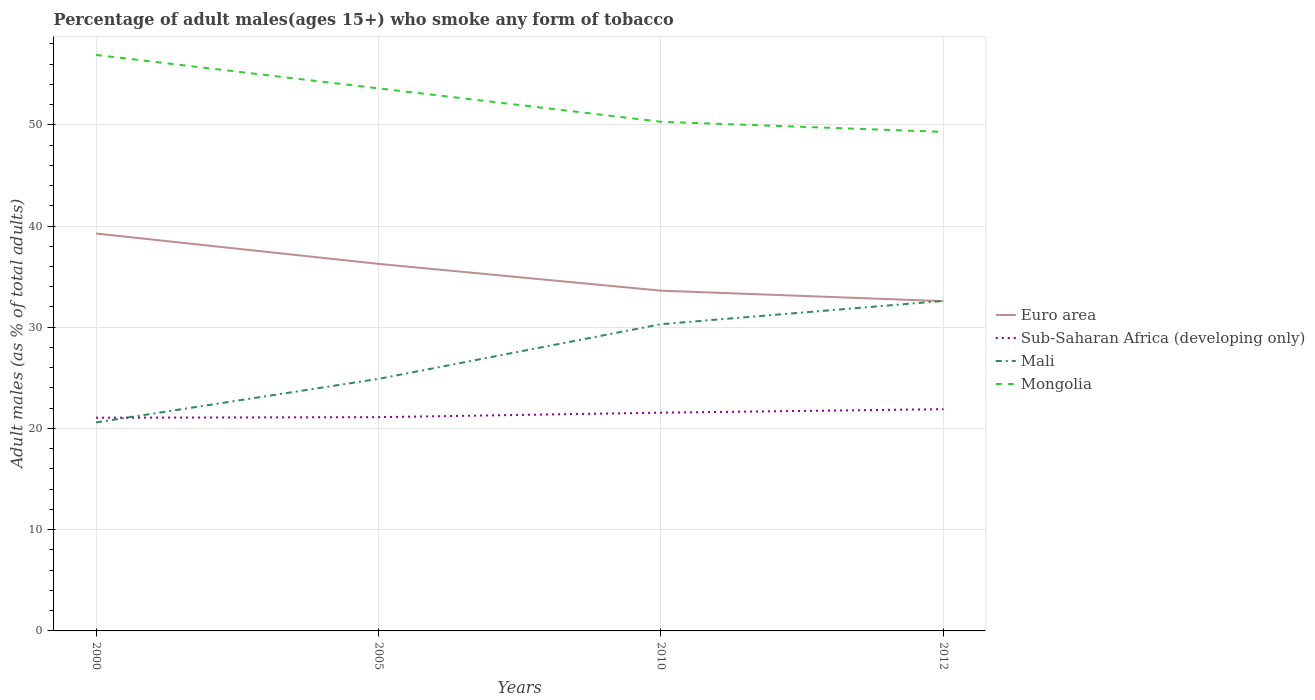How many different coloured lines are there?
Keep it short and to the point. 4. Across all years, what is the maximum percentage of adult males who smoke in Mongolia?
Give a very brief answer. 49.3. What is the total percentage of adult males who smoke in Euro area in the graph?
Your answer should be very brief. 3.68. What is the difference between the highest and the second highest percentage of adult males who smoke in Euro area?
Make the answer very short. 6.68. Is the percentage of adult males who smoke in Sub-Saharan Africa (developing only) strictly greater than the percentage of adult males who smoke in Mongolia over the years?
Make the answer very short. Yes. How many lines are there?
Your response must be concise. 4. How many years are there in the graph?
Provide a short and direct response. 4. Are the values on the major ticks of Y-axis written in scientific E-notation?
Give a very brief answer. No. Does the graph contain grids?
Offer a terse response. Yes. Where does the legend appear in the graph?
Provide a short and direct response. Center right. What is the title of the graph?
Keep it short and to the point. Percentage of adult males(ages 15+) who smoke any form of tobacco. What is the label or title of the Y-axis?
Make the answer very short. Adult males (as % of total adults). What is the Adult males (as % of total adults) in Euro area in 2000?
Give a very brief answer. 39.26. What is the Adult males (as % of total adults) in Sub-Saharan Africa (developing only) in 2000?
Offer a very short reply. 21.06. What is the Adult males (as % of total adults) of Mali in 2000?
Your answer should be very brief. 20.6. What is the Adult males (as % of total adults) of Mongolia in 2000?
Offer a very short reply. 56.9. What is the Adult males (as % of total adults) of Euro area in 2005?
Offer a terse response. 36.26. What is the Adult males (as % of total adults) in Sub-Saharan Africa (developing only) in 2005?
Provide a succinct answer. 21.12. What is the Adult males (as % of total adults) of Mali in 2005?
Your answer should be very brief. 24.9. What is the Adult males (as % of total adults) of Mongolia in 2005?
Provide a succinct answer. 53.6. What is the Adult males (as % of total adults) of Euro area in 2010?
Your response must be concise. 33.61. What is the Adult males (as % of total adults) of Sub-Saharan Africa (developing only) in 2010?
Your answer should be compact. 21.56. What is the Adult males (as % of total adults) of Mali in 2010?
Provide a succinct answer. 30.3. What is the Adult males (as % of total adults) in Mongolia in 2010?
Make the answer very short. 50.3. What is the Adult males (as % of total adults) in Euro area in 2012?
Your response must be concise. 32.58. What is the Adult males (as % of total adults) of Sub-Saharan Africa (developing only) in 2012?
Give a very brief answer. 21.91. What is the Adult males (as % of total adults) of Mali in 2012?
Ensure brevity in your answer.  32.6. What is the Adult males (as % of total adults) of Mongolia in 2012?
Offer a terse response. 49.3. Across all years, what is the maximum Adult males (as % of total adults) in Euro area?
Keep it short and to the point. 39.26. Across all years, what is the maximum Adult males (as % of total adults) in Sub-Saharan Africa (developing only)?
Your answer should be compact. 21.91. Across all years, what is the maximum Adult males (as % of total adults) in Mali?
Provide a succinct answer. 32.6. Across all years, what is the maximum Adult males (as % of total adults) in Mongolia?
Offer a terse response. 56.9. Across all years, what is the minimum Adult males (as % of total adults) of Euro area?
Give a very brief answer. 32.58. Across all years, what is the minimum Adult males (as % of total adults) in Sub-Saharan Africa (developing only)?
Your response must be concise. 21.06. Across all years, what is the minimum Adult males (as % of total adults) of Mali?
Keep it short and to the point. 20.6. Across all years, what is the minimum Adult males (as % of total adults) of Mongolia?
Your answer should be very brief. 49.3. What is the total Adult males (as % of total adults) of Euro area in the graph?
Keep it short and to the point. 141.71. What is the total Adult males (as % of total adults) in Sub-Saharan Africa (developing only) in the graph?
Offer a terse response. 85.64. What is the total Adult males (as % of total adults) in Mali in the graph?
Your answer should be compact. 108.4. What is the total Adult males (as % of total adults) in Mongolia in the graph?
Your answer should be very brief. 210.1. What is the difference between the Adult males (as % of total adults) in Euro area in 2000 and that in 2005?
Keep it short and to the point. 3. What is the difference between the Adult males (as % of total adults) in Sub-Saharan Africa (developing only) in 2000 and that in 2005?
Keep it short and to the point. -0.06. What is the difference between the Adult males (as % of total adults) of Mongolia in 2000 and that in 2005?
Provide a short and direct response. 3.3. What is the difference between the Adult males (as % of total adults) of Euro area in 2000 and that in 2010?
Ensure brevity in your answer.  5.64. What is the difference between the Adult males (as % of total adults) of Sub-Saharan Africa (developing only) in 2000 and that in 2010?
Offer a very short reply. -0.5. What is the difference between the Adult males (as % of total adults) in Euro area in 2000 and that in 2012?
Give a very brief answer. 6.68. What is the difference between the Adult males (as % of total adults) of Sub-Saharan Africa (developing only) in 2000 and that in 2012?
Your response must be concise. -0.85. What is the difference between the Adult males (as % of total adults) of Mali in 2000 and that in 2012?
Give a very brief answer. -12. What is the difference between the Adult males (as % of total adults) in Mongolia in 2000 and that in 2012?
Offer a terse response. 7.6. What is the difference between the Adult males (as % of total adults) in Euro area in 2005 and that in 2010?
Offer a terse response. 2.65. What is the difference between the Adult males (as % of total adults) in Sub-Saharan Africa (developing only) in 2005 and that in 2010?
Provide a short and direct response. -0.44. What is the difference between the Adult males (as % of total adults) of Mali in 2005 and that in 2010?
Your answer should be compact. -5.4. What is the difference between the Adult males (as % of total adults) in Euro area in 2005 and that in 2012?
Your answer should be very brief. 3.68. What is the difference between the Adult males (as % of total adults) in Sub-Saharan Africa (developing only) in 2005 and that in 2012?
Your answer should be very brief. -0.79. What is the difference between the Adult males (as % of total adults) in Mongolia in 2005 and that in 2012?
Keep it short and to the point. 4.3. What is the difference between the Adult males (as % of total adults) of Euro area in 2010 and that in 2012?
Your response must be concise. 1.03. What is the difference between the Adult males (as % of total adults) in Sub-Saharan Africa (developing only) in 2010 and that in 2012?
Offer a terse response. -0.35. What is the difference between the Adult males (as % of total adults) of Mali in 2010 and that in 2012?
Your response must be concise. -2.3. What is the difference between the Adult males (as % of total adults) of Mongolia in 2010 and that in 2012?
Keep it short and to the point. 1. What is the difference between the Adult males (as % of total adults) of Euro area in 2000 and the Adult males (as % of total adults) of Sub-Saharan Africa (developing only) in 2005?
Offer a terse response. 18.14. What is the difference between the Adult males (as % of total adults) of Euro area in 2000 and the Adult males (as % of total adults) of Mali in 2005?
Make the answer very short. 14.36. What is the difference between the Adult males (as % of total adults) in Euro area in 2000 and the Adult males (as % of total adults) in Mongolia in 2005?
Keep it short and to the point. -14.34. What is the difference between the Adult males (as % of total adults) in Sub-Saharan Africa (developing only) in 2000 and the Adult males (as % of total adults) in Mali in 2005?
Provide a succinct answer. -3.84. What is the difference between the Adult males (as % of total adults) in Sub-Saharan Africa (developing only) in 2000 and the Adult males (as % of total adults) in Mongolia in 2005?
Offer a very short reply. -32.54. What is the difference between the Adult males (as % of total adults) in Mali in 2000 and the Adult males (as % of total adults) in Mongolia in 2005?
Give a very brief answer. -33. What is the difference between the Adult males (as % of total adults) of Euro area in 2000 and the Adult males (as % of total adults) of Sub-Saharan Africa (developing only) in 2010?
Offer a very short reply. 17.7. What is the difference between the Adult males (as % of total adults) of Euro area in 2000 and the Adult males (as % of total adults) of Mali in 2010?
Keep it short and to the point. 8.96. What is the difference between the Adult males (as % of total adults) in Euro area in 2000 and the Adult males (as % of total adults) in Mongolia in 2010?
Offer a terse response. -11.04. What is the difference between the Adult males (as % of total adults) in Sub-Saharan Africa (developing only) in 2000 and the Adult males (as % of total adults) in Mali in 2010?
Give a very brief answer. -9.24. What is the difference between the Adult males (as % of total adults) of Sub-Saharan Africa (developing only) in 2000 and the Adult males (as % of total adults) of Mongolia in 2010?
Provide a short and direct response. -29.24. What is the difference between the Adult males (as % of total adults) of Mali in 2000 and the Adult males (as % of total adults) of Mongolia in 2010?
Provide a short and direct response. -29.7. What is the difference between the Adult males (as % of total adults) of Euro area in 2000 and the Adult males (as % of total adults) of Sub-Saharan Africa (developing only) in 2012?
Provide a short and direct response. 17.35. What is the difference between the Adult males (as % of total adults) of Euro area in 2000 and the Adult males (as % of total adults) of Mali in 2012?
Your response must be concise. 6.66. What is the difference between the Adult males (as % of total adults) in Euro area in 2000 and the Adult males (as % of total adults) in Mongolia in 2012?
Ensure brevity in your answer.  -10.04. What is the difference between the Adult males (as % of total adults) in Sub-Saharan Africa (developing only) in 2000 and the Adult males (as % of total adults) in Mali in 2012?
Ensure brevity in your answer.  -11.54. What is the difference between the Adult males (as % of total adults) of Sub-Saharan Africa (developing only) in 2000 and the Adult males (as % of total adults) of Mongolia in 2012?
Offer a terse response. -28.24. What is the difference between the Adult males (as % of total adults) in Mali in 2000 and the Adult males (as % of total adults) in Mongolia in 2012?
Provide a short and direct response. -28.7. What is the difference between the Adult males (as % of total adults) in Euro area in 2005 and the Adult males (as % of total adults) in Sub-Saharan Africa (developing only) in 2010?
Ensure brevity in your answer.  14.7. What is the difference between the Adult males (as % of total adults) in Euro area in 2005 and the Adult males (as % of total adults) in Mali in 2010?
Give a very brief answer. 5.96. What is the difference between the Adult males (as % of total adults) in Euro area in 2005 and the Adult males (as % of total adults) in Mongolia in 2010?
Your answer should be very brief. -14.04. What is the difference between the Adult males (as % of total adults) in Sub-Saharan Africa (developing only) in 2005 and the Adult males (as % of total adults) in Mali in 2010?
Offer a very short reply. -9.18. What is the difference between the Adult males (as % of total adults) in Sub-Saharan Africa (developing only) in 2005 and the Adult males (as % of total adults) in Mongolia in 2010?
Keep it short and to the point. -29.18. What is the difference between the Adult males (as % of total adults) of Mali in 2005 and the Adult males (as % of total adults) of Mongolia in 2010?
Keep it short and to the point. -25.4. What is the difference between the Adult males (as % of total adults) of Euro area in 2005 and the Adult males (as % of total adults) of Sub-Saharan Africa (developing only) in 2012?
Keep it short and to the point. 14.36. What is the difference between the Adult males (as % of total adults) in Euro area in 2005 and the Adult males (as % of total adults) in Mali in 2012?
Your response must be concise. 3.66. What is the difference between the Adult males (as % of total adults) of Euro area in 2005 and the Adult males (as % of total adults) of Mongolia in 2012?
Ensure brevity in your answer.  -13.04. What is the difference between the Adult males (as % of total adults) in Sub-Saharan Africa (developing only) in 2005 and the Adult males (as % of total adults) in Mali in 2012?
Ensure brevity in your answer.  -11.48. What is the difference between the Adult males (as % of total adults) in Sub-Saharan Africa (developing only) in 2005 and the Adult males (as % of total adults) in Mongolia in 2012?
Make the answer very short. -28.18. What is the difference between the Adult males (as % of total adults) in Mali in 2005 and the Adult males (as % of total adults) in Mongolia in 2012?
Make the answer very short. -24.4. What is the difference between the Adult males (as % of total adults) in Euro area in 2010 and the Adult males (as % of total adults) in Sub-Saharan Africa (developing only) in 2012?
Your answer should be very brief. 11.71. What is the difference between the Adult males (as % of total adults) of Euro area in 2010 and the Adult males (as % of total adults) of Mali in 2012?
Your answer should be compact. 1.01. What is the difference between the Adult males (as % of total adults) of Euro area in 2010 and the Adult males (as % of total adults) of Mongolia in 2012?
Offer a very short reply. -15.69. What is the difference between the Adult males (as % of total adults) of Sub-Saharan Africa (developing only) in 2010 and the Adult males (as % of total adults) of Mali in 2012?
Provide a succinct answer. -11.04. What is the difference between the Adult males (as % of total adults) of Sub-Saharan Africa (developing only) in 2010 and the Adult males (as % of total adults) of Mongolia in 2012?
Provide a succinct answer. -27.74. What is the average Adult males (as % of total adults) in Euro area per year?
Your response must be concise. 35.43. What is the average Adult males (as % of total adults) of Sub-Saharan Africa (developing only) per year?
Provide a short and direct response. 21.41. What is the average Adult males (as % of total adults) of Mali per year?
Offer a terse response. 27.1. What is the average Adult males (as % of total adults) in Mongolia per year?
Your answer should be compact. 52.52. In the year 2000, what is the difference between the Adult males (as % of total adults) of Euro area and Adult males (as % of total adults) of Sub-Saharan Africa (developing only)?
Ensure brevity in your answer.  18.2. In the year 2000, what is the difference between the Adult males (as % of total adults) of Euro area and Adult males (as % of total adults) of Mali?
Make the answer very short. 18.66. In the year 2000, what is the difference between the Adult males (as % of total adults) of Euro area and Adult males (as % of total adults) of Mongolia?
Make the answer very short. -17.64. In the year 2000, what is the difference between the Adult males (as % of total adults) in Sub-Saharan Africa (developing only) and Adult males (as % of total adults) in Mali?
Your answer should be compact. 0.46. In the year 2000, what is the difference between the Adult males (as % of total adults) in Sub-Saharan Africa (developing only) and Adult males (as % of total adults) in Mongolia?
Your answer should be compact. -35.84. In the year 2000, what is the difference between the Adult males (as % of total adults) of Mali and Adult males (as % of total adults) of Mongolia?
Offer a terse response. -36.3. In the year 2005, what is the difference between the Adult males (as % of total adults) of Euro area and Adult males (as % of total adults) of Sub-Saharan Africa (developing only)?
Your response must be concise. 15.14. In the year 2005, what is the difference between the Adult males (as % of total adults) of Euro area and Adult males (as % of total adults) of Mali?
Give a very brief answer. 11.36. In the year 2005, what is the difference between the Adult males (as % of total adults) of Euro area and Adult males (as % of total adults) of Mongolia?
Keep it short and to the point. -17.34. In the year 2005, what is the difference between the Adult males (as % of total adults) of Sub-Saharan Africa (developing only) and Adult males (as % of total adults) of Mali?
Offer a terse response. -3.78. In the year 2005, what is the difference between the Adult males (as % of total adults) of Sub-Saharan Africa (developing only) and Adult males (as % of total adults) of Mongolia?
Offer a terse response. -32.48. In the year 2005, what is the difference between the Adult males (as % of total adults) of Mali and Adult males (as % of total adults) of Mongolia?
Keep it short and to the point. -28.7. In the year 2010, what is the difference between the Adult males (as % of total adults) of Euro area and Adult males (as % of total adults) of Sub-Saharan Africa (developing only)?
Keep it short and to the point. 12.05. In the year 2010, what is the difference between the Adult males (as % of total adults) of Euro area and Adult males (as % of total adults) of Mali?
Your answer should be very brief. 3.31. In the year 2010, what is the difference between the Adult males (as % of total adults) of Euro area and Adult males (as % of total adults) of Mongolia?
Your response must be concise. -16.69. In the year 2010, what is the difference between the Adult males (as % of total adults) of Sub-Saharan Africa (developing only) and Adult males (as % of total adults) of Mali?
Your answer should be very brief. -8.74. In the year 2010, what is the difference between the Adult males (as % of total adults) in Sub-Saharan Africa (developing only) and Adult males (as % of total adults) in Mongolia?
Your answer should be very brief. -28.74. In the year 2012, what is the difference between the Adult males (as % of total adults) of Euro area and Adult males (as % of total adults) of Sub-Saharan Africa (developing only)?
Offer a terse response. 10.67. In the year 2012, what is the difference between the Adult males (as % of total adults) of Euro area and Adult males (as % of total adults) of Mali?
Ensure brevity in your answer.  -0.02. In the year 2012, what is the difference between the Adult males (as % of total adults) of Euro area and Adult males (as % of total adults) of Mongolia?
Offer a very short reply. -16.72. In the year 2012, what is the difference between the Adult males (as % of total adults) in Sub-Saharan Africa (developing only) and Adult males (as % of total adults) in Mali?
Provide a succinct answer. -10.69. In the year 2012, what is the difference between the Adult males (as % of total adults) of Sub-Saharan Africa (developing only) and Adult males (as % of total adults) of Mongolia?
Provide a short and direct response. -27.39. In the year 2012, what is the difference between the Adult males (as % of total adults) in Mali and Adult males (as % of total adults) in Mongolia?
Your answer should be very brief. -16.7. What is the ratio of the Adult males (as % of total adults) of Euro area in 2000 to that in 2005?
Ensure brevity in your answer.  1.08. What is the ratio of the Adult males (as % of total adults) in Sub-Saharan Africa (developing only) in 2000 to that in 2005?
Provide a short and direct response. 1. What is the ratio of the Adult males (as % of total adults) in Mali in 2000 to that in 2005?
Offer a very short reply. 0.83. What is the ratio of the Adult males (as % of total adults) in Mongolia in 2000 to that in 2005?
Provide a short and direct response. 1.06. What is the ratio of the Adult males (as % of total adults) in Euro area in 2000 to that in 2010?
Offer a very short reply. 1.17. What is the ratio of the Adult males (as % of total adults) of Sub-Saharan Africa (developing only) in 2000 to that in 2010?
Make the answer very short. 0.98. What is the ratio of the Adult males (as % of total adults) of Mali in 2000 to that in 2010?
Give a very brief answer. 0.68. What is the ratio of the Adult males (as % of total adults) of Mongolia in 2000 to that in 2010?
Your response must be concise. 1.13. What is the ratio of the Adult males (as % of total adults) in Euro area in 2000 to that in 2012?
Your answer should be compact. 1.21. What is the ratio of the Adult males (as % of total adults) of Sub-Saharan Africa (developing only) in 2000 to that in 2012?
Ensure brevity in your answer.  0.96. What is the ratio of the Adult males (as % of total adults) in Mali in 2000 to that in 2012?
Provide a short and direct response. 0.63. What is the ratio of the Adult males (as % of total adults) in Mongolia in 2000 to that in 2012?
Ensure brevity in your answer.  1.15. What is the ratio of the Adult males (as % of total adults) of Euro area in 2005 to that in 2010?
Make the answer very short. 1.08. What is the ratio of the Adult males (as % of total adults) of Sub-Saharan Africa (developing only) in 2005 to that in 2010?
Offer a terse response. 0.98. What is the ratio of the Adult males (as % of total adults) in Mali in 2005 to that in 2010?
Your response must be concise. 0.82. What is the ratio of the Adult males (as % of total adults) of Mongolia in 2005 to that in 2010?
Your answer should be very brief. 1.07. What is the ratio of the Adult males (as % of total adults) in Euro area in 2005 to that in 2012?
Provide a short and direct response. 1.11. What is the ratio of the Adult males (as % of total adults) in Sub-Saharan Africa (developing only) in 2005 to that in 2012?
Your answer should be very brief. 0.96. What is the ratio of the Adult males (as % of total adults) in Mali in 2005 to that in 2012?
Offer a terse response. 0.76. What is the ratio of the Adult males (as % of total adults) of Mongolia in 2005 to that in 2012?
Your answer should be compact. 1.09. What is the ratio of the Adult males (as % of total adults) in Euro area in 2010 to that in 2012?
Offer a terse response. 1.03. What is the ratio of the Adult males (as % of total adults) of Sub-Saharan Africa (developing only) in 2010 to that in 2012?
Provide a succinct answer. 0.98. What is the ratio of the Adult males (as % of total adults) of Mali in 2010 to that in 2012?
Your answer should be compact. 0.93. What is the ratio of the Adult males (as % of total adults) of Mongolia in 2010 to that in 2012?
Offer a very short reply. 1.02. What is the difference between the highest and the second highest Adult males (as % of total adults) in Euro area?
Your answer should be very brief. 3. What is the difference between the highest and the second highest Adult males (as % of total adults) of Sub-Saharan Africa (developing only)?
Your answer should be very brief. 0.35. What is the difference between the highest and the second highest Adult males (as % of total adults) of Mali?
Offer a terse response. 2.3. What is the difference between the highest and the lowest Adult males (as % of total adults) of Euro area?
Give a very brief answer. 6.68. What is the difference between the highest and the lowest Adult males (as % of total adults) of Sub-Saharan Africa (developing only)?
Your answer should be very brief. 0.85. What is the difference between the highest and the lowest Adult males (as % of total adults) in Mali?
Provide a succinct answer. 12. What is the difference between the highest and the lowest Adult males (as % of total adults) of Mongolia?
Give a very brief answer. 7.6. 